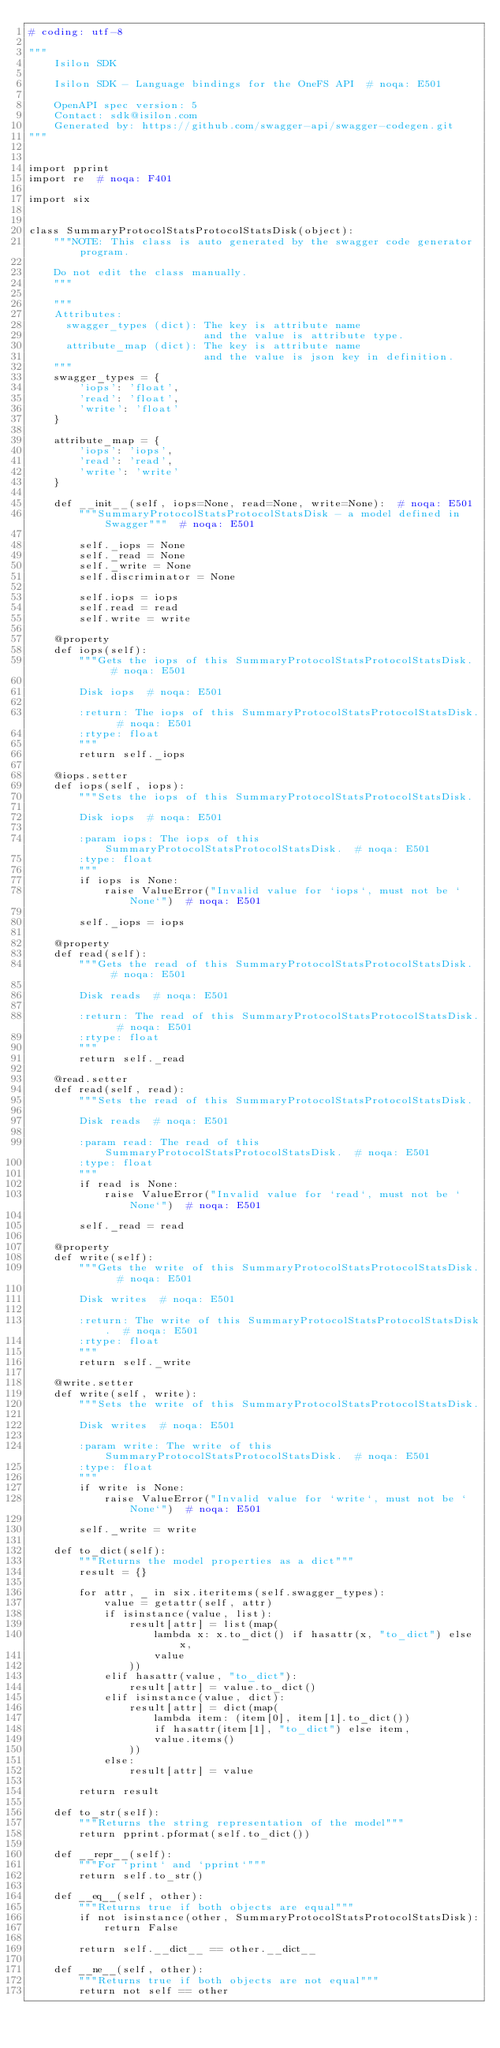Convert code to text. <code><loc_0><loc_0><loc_500><loc_500><_Python_># coding: utf-8

"""
    Isilon SDK

    Isilon SDK - Language bindings for the OneFS API  # noqa: E501

    OpenAPI spec version: 5
    Contact: sdk@isilon.com
    Generated by: https://github.com/swagger-api/swagger-codegen.git
"""


import pprint
import re  # noqa: F401

import six


class SummaryProtocolStatsProtocolStatsDisk(object):
    """NOTE: This class is auto generated by the swagger code generator program.

    Do not edit the class manually.
    """

    """
    Attributes:
      swagger_types (dict): The key is attribute name
                            and the value is attribute type.
      attribute_map (dict): The key is attribute name
                            and the value is json key in definition.
    """
    swagger_types = {
        'iops': 'float',
        'read': 'float',
        'write': 'float'
    }

    attribute_map = {
        'iops': 'iops',
        'read': 'read',
        'write': 'write'
    }

    def __init__(self, iops=None, read=None, write=None):  # noqa: E501
        """SummaryProtocolStatsProtocolStatsDisk - a model defined in Swagger"""  # noqa: E501

        self._iops = None
        self._read = None
        self._write = None
        self.discriminator = None

        self.iops = iops
        self.read = read
        self.write = write

    @property
    def iops(self):
        """Gets the iops of this SummaryProtocolStatsProtocolStatsDisk.  # noqa: E501

        Disk iops  # noqa: E501

        :return: The iops of this SummaryProtocolStatsProtocolStatsDisk.  # noqa: E501
        :rtype: float
        """
        return self._iops

    @iops.setter
    def iops(self, iops):
        """Sets the iops of this SummaryProtocolStatsProtocolStatsDisk.

        Disk iops  # noqa: E501

        :param iops: The iops of this SummaryProtocolStatsProtocolStatsDisk.  # noqa: E501
        :type: float
        """
        if iops is None:
            raise ValueError("Invalid value for `iops`, must not be `None`")  # noqa: E501

        self._iops = iops

    @property
    def read(self):
        """Gets the read of this SummaryProtocolStatsProtocolStatsDisk.  # noqa: E501

        Disk reads  # noqa: E501

        :return: The read of this SummaryProtocolStatsProtocolStatsDisk.  # noqa: E501
        :rtype: float
        """
        return self._read

    @read.setter
    def read(self, read):
        """Sets the read of this SummaryProtocolStatsProtocolStatsDisk.

        Disk reads  # noqa: E501

        :param read: The read of this SummaryProtocolStatsProtocolStatsDisk.  # noqa: E501
        :type: float
        """
        if read is None:
            raise ValueError("Invalid value for `read`, must not be `None`")  # noqa: E501

        self._read = read

    @property
    def write(self):
        """Gets the write of this SummaryProtocolStatsProtocolStatsDisk.  # noqa: E501

        Disk writes  # noqa: E501

        :return: The write of this SummaryProtocolStatsProtocolStatsDisk.  # noqa: E501
        :rtype: float
        """
        return self._write

    @write.setter
    def write(self, write):
        """Sets the write of this SummaryProtocolStatsProtocolStatsDisk.

        Disk writes  # noqa: E501

        :param write: The write of this SummaryProtocolStatsProtocolStatsDisk.  # noqa: E501
        :type: float
        """
        if write is None:
            raise ValueError("Invalid value for `write`, must not be `None`")  # noqa: E501

        self._write = write

    def to_dict(self):
        """Returns the model properties as a dict"""
        result = {}

        for attr, _ in six.iteritems(self.swagger_types):
            value = getattr(self, attr)
            if isinstance(value, list):
                result[attr] = list(map(
                    lambda x: x.to_dict() if hasattr(x, "to_dict") else x,
                    value
                ))
            elif hasattr(value, "to_dict"):
                result[attr] = value.to_dict()
            elif isinstance(value, dict):
                result[attr] = dict(map(
                    lambda item: (item[0], item[1].to_dict())
                    if hasattr(item[1], "to_dict") else item,
                    value.items()
                ))
            else:
                result[attr] = value

        return result

    def to_str(self):
        """Returns the string representation of the model"""
        return pprint.pformat(self.to_dict())

    def __repr__(self):
        """For `print` and `pprint`"""
        return self.to_str()

    def __eq__(self, other):
        """Returns true if both objects are equal"""
        if not isinstance(other, SummaryProtocolStatsProtocolStatsDisk):
            return False

        return self.__dict__ == other.__dict__

    def __ne__(self, other):
        """Returns true if both objects are not equal"""
        return not self == other
</code> 